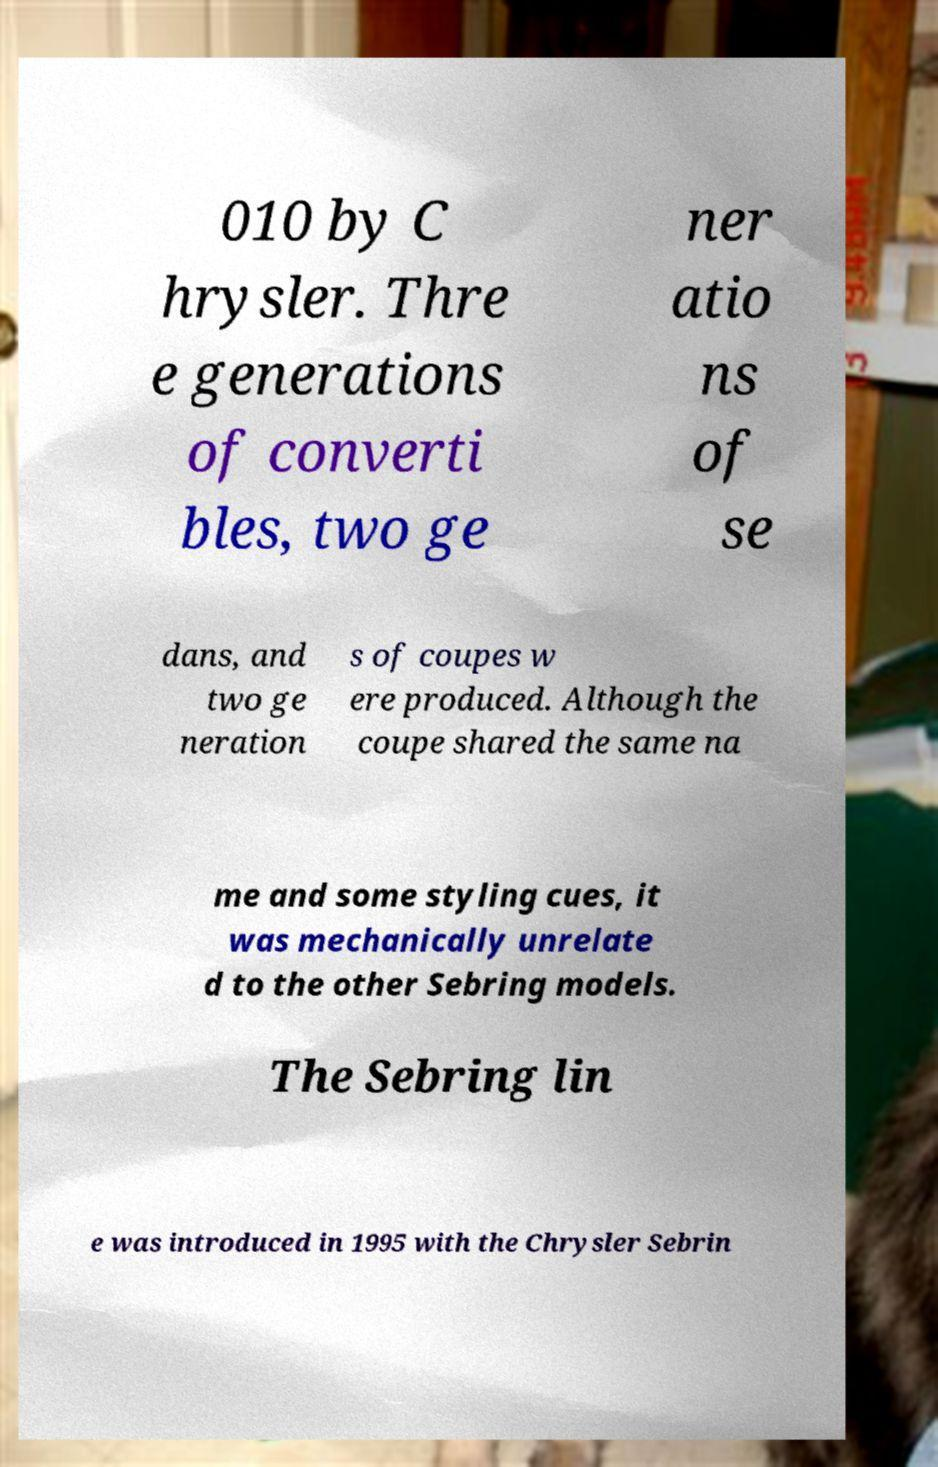Please identify and transcribe the text found in this image. 010 by C hrysler. Thre e generations of converti bles, two ge ner atio ns of se dans, and two ge neration s of coupes w ere produced. Although the coupe shared the same na me and some styling cues, it was mechanically unrelate d to the other Sebring models. The Sebring lin e was introduced in 1995 with the Chrysler Sebrin 